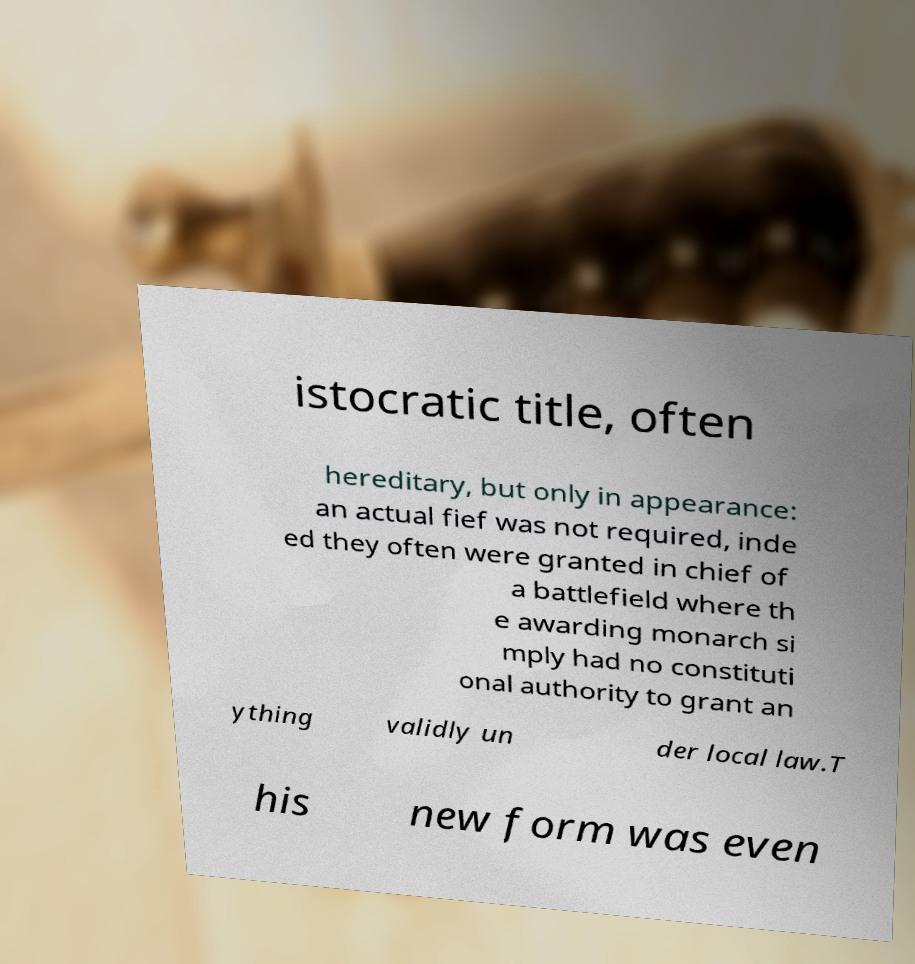Could you assist in decoding the text presented in this image and type it out clearly? istocratic title, often hereditary, but only in appearance: an actual fief was not required, inde ed they often were granted in chief of a battlefield where th e awarding monarch si mply had no constituti onal authority to grant an ything validly un der local law.T his new form was even 